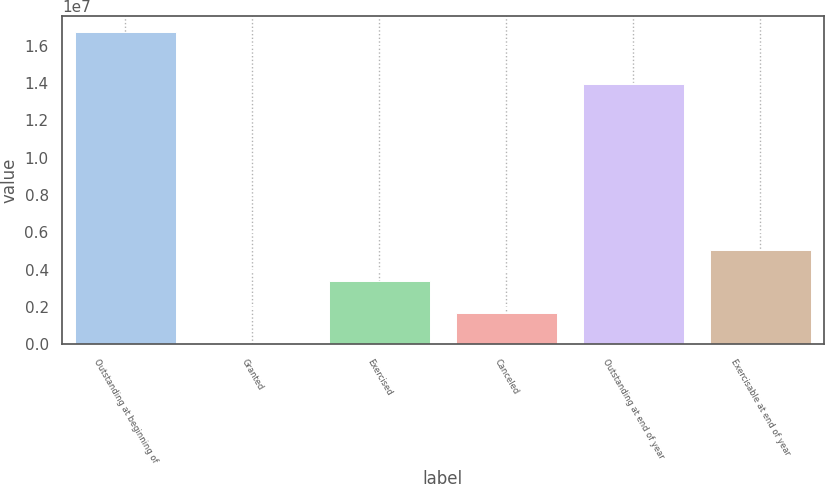<chart> <loc_0><loc_0><loc_500><loc_500><bar_chart><fcel>Outstanding at beginning of<fcel>Granted<fcel>Exercised<fcel>Canceled<fcel>Outstanding at end of year<fcel>Exercisable at end of year<nl><fcel>1.67334e+07<fcel>30000<fcel>3.37068e+06<fcel>1.70034e+06<fcel>1.39656e+07<fcel>5.04102e+06<nl></chart> 